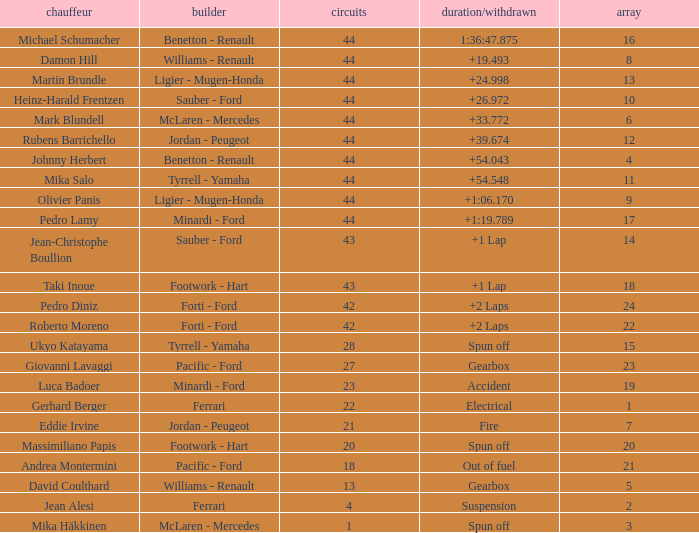What is the high lap total for cards with a grid larger than 21, and a Time/Retired of +2 laps? 42.0. 